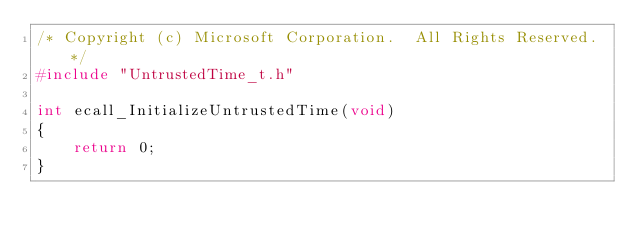<code> <loc_0><loc_0><loc_500><loc_500><_C_>/* Copyright (c) Microsoft Corporation.  All Rights Reserved. */
#include "UntrustedTime_t.h"

int ecall_InitializeUntrustedTime(void)
{
    return 0;
}
</code> 